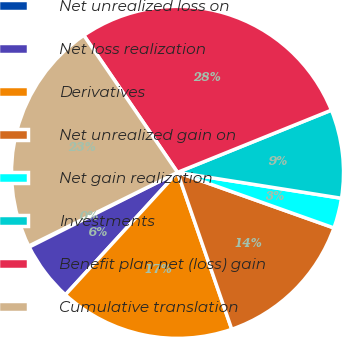Convert chart. <chart><loc_0><loc_0><loc_500><loc_500><pie_chart><fcel>Net unrealized loss on<fcel>Net loss realization<fcel>Derivatives<fcel>Net unrealized gain on<fcel>Net gain realization<fcel>Investments<fcel>Benefit plan net (loss) gain<fcel>Cumulative translation<nl><fcel>0.11%<fcel>5.77%<fcel>17.1%<fcel>14.27%<fcel>2.94%<fcel>8.61%<fcel>28.43%<fcel>22.77%<nl></chart> 